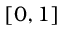<formula> <loc_0><loc_0><loc_500><loc_500>\left [ 0 , 1 \right ]</formula> 